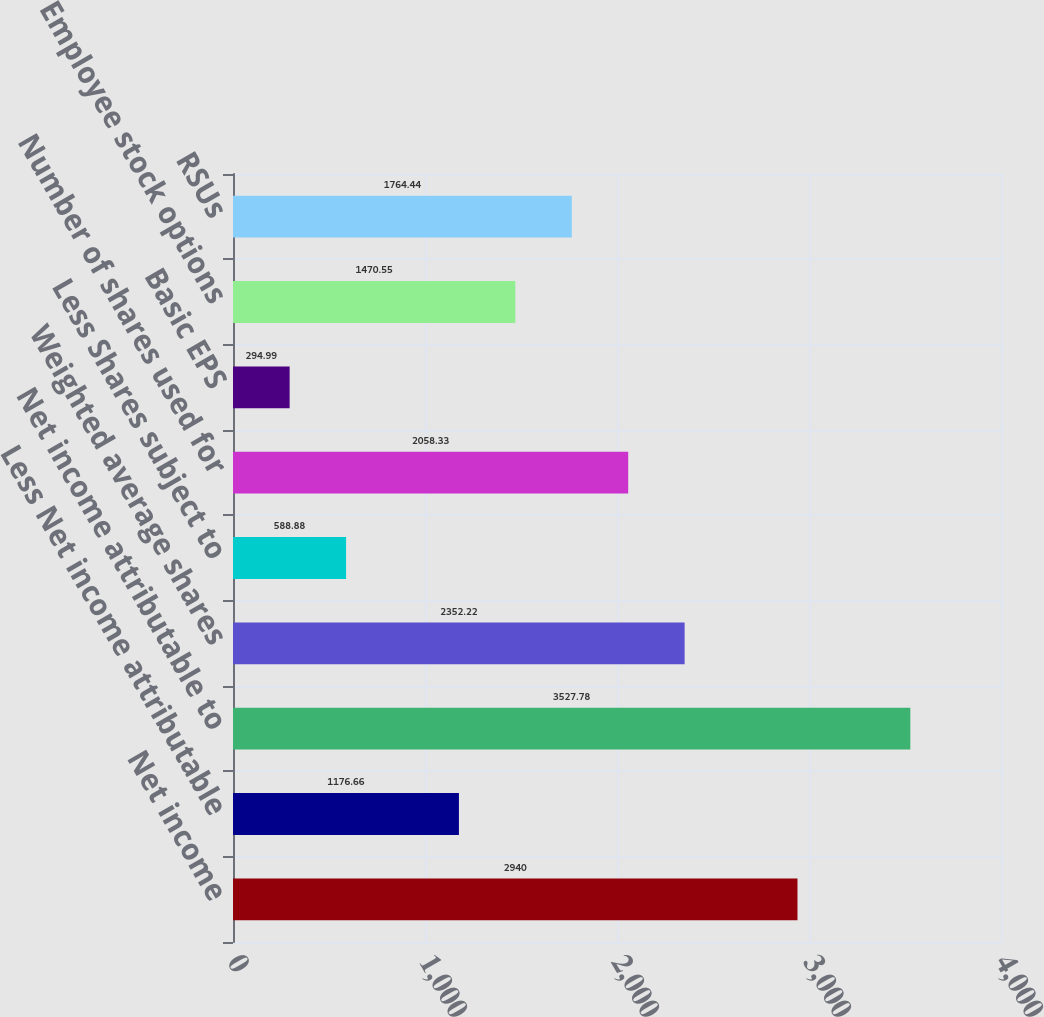Convert chart to OTSL. <chart><loc_0><loc_0><loc_500><loc_500><bar_chart><fcel>Net income<fcel>Less Net income attributable<fcel>Net income attributable to<fcel>Weighted average shares<fcel>Less Shares subject to<fcel>Number of shares used for<fcel>Basic EPS<fcel>Employee stock options<fcel>RSUs<nl><fcel>2940<fcel>1176.66<fcel>3527.78<fcel>2352.22<fcel>588.88<fcel>2058.33<fcel>294.99<fcel>1470.55<fcel>1764.44<nl></chart> 